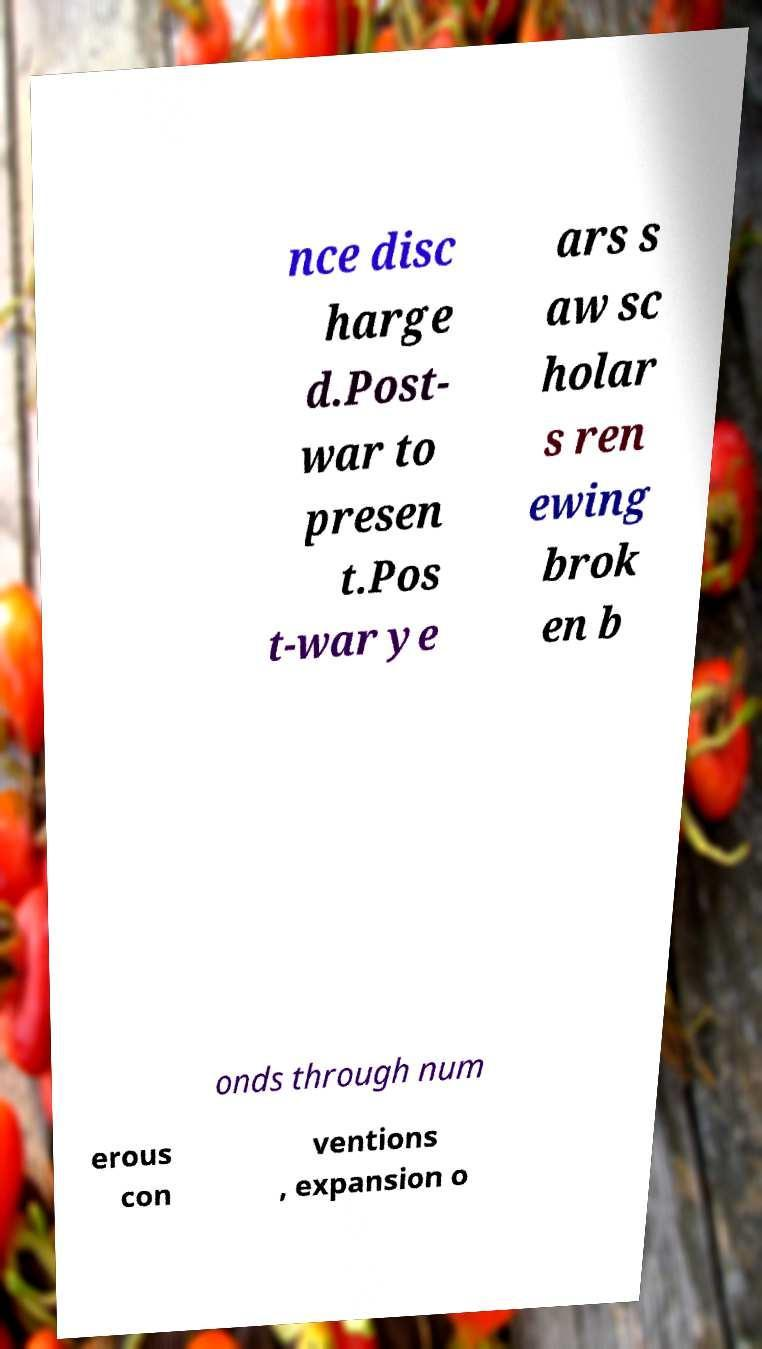What messages or text are displayed in this image? I need them in a readable, typed format. nce disc harge d.Post- war to presen t.Pos t-war ye ars s aw sc holar s ren ewing brok en b onds through num erous con ventions , expansion o 